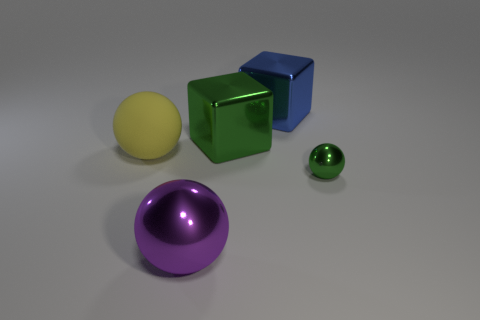Subtract all purple metallic balls. How many balls are left? 2 Add 2 big yellow spheres. How many objects exist? 7 Subtract all blue cubes. How many cubes are left? 1 Subtract 1 blocks. How many blocks are left? 1 Subtract all blocks. How many objects are left? 3 Subtract all brown blocks. Subtract all green cylinders. How many blocks are left? 2 Subtract all large spheres. Subtract all metal spheres. How many objects are left? 1 Add 2 big blue blocks. How many big blue blocks are left? 3 Add 1 large purple shiny objects. How many large purple shiny objects exist? 2 Subtract 0 yellow cylinders. How many objects are left? 5 